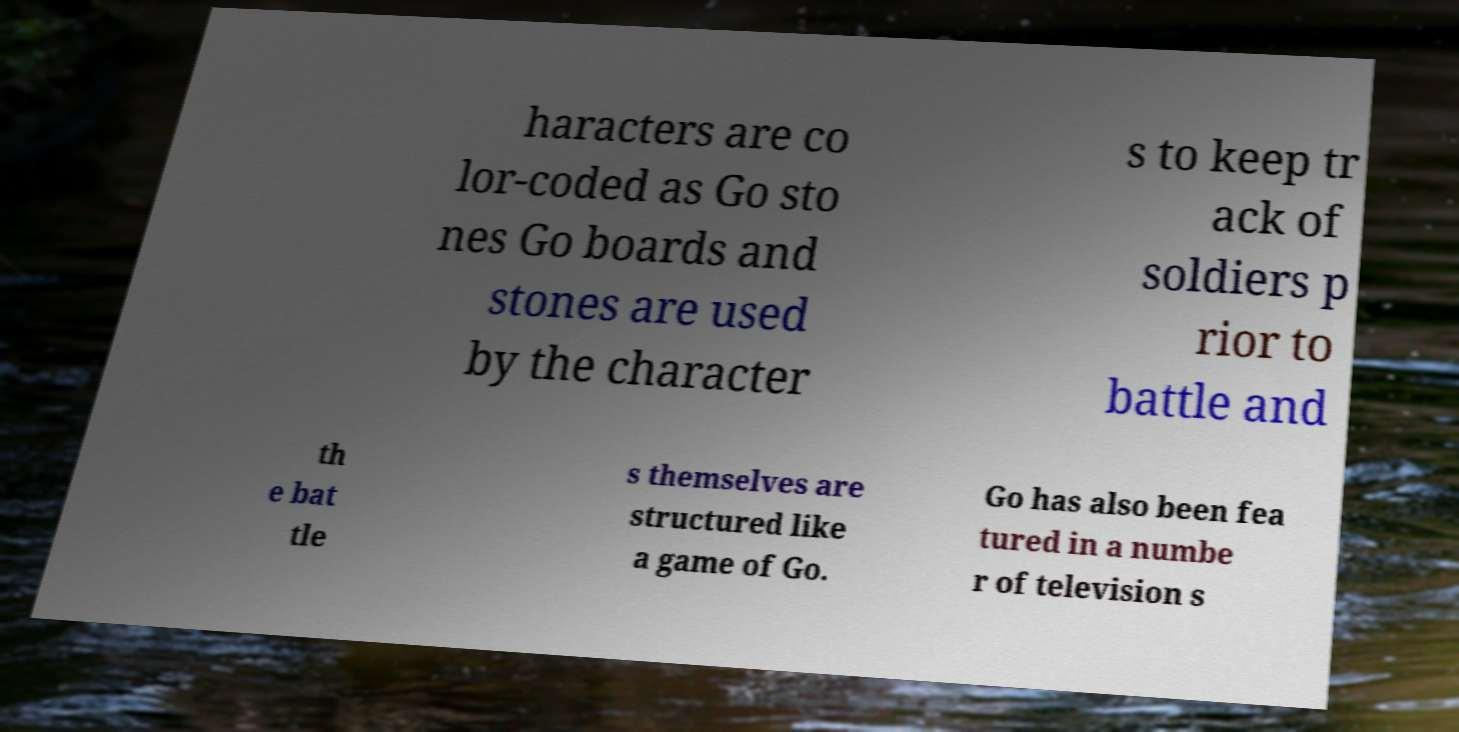Could you extract and type out the text from this image? haracters are co lor-coded as Go sto nes Go boards and stones are used by the character s to keep tr ack of soldiers p rior to battle and th e bat tle s themselves are structured like a game of Go. Go has also been fea tured in a numbe r of television s 